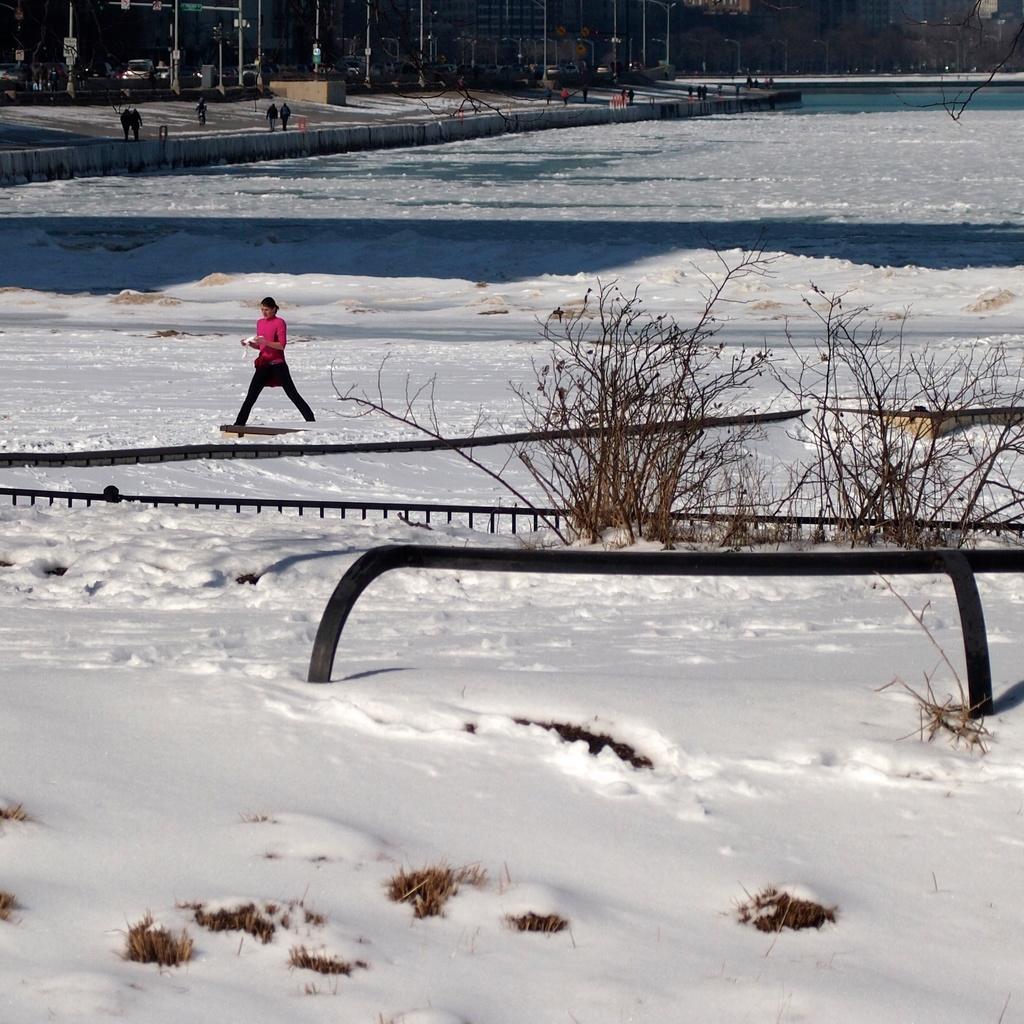Can you describe this image briefly? In this image, we can see a person skating on the snow and in the background, we can see poles and some people and we can see some trees. 